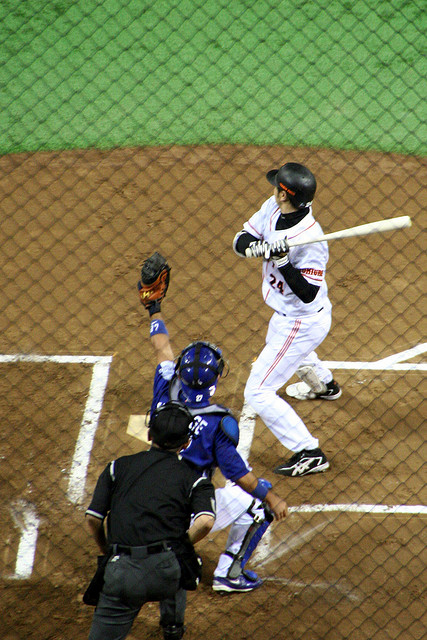Read and extract the text from this image. 24 